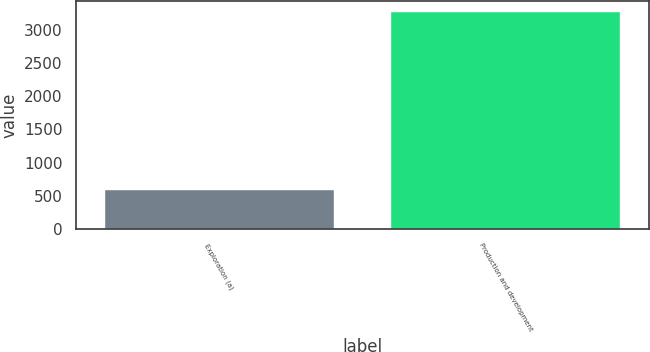Convert chart. <chart><loc_0><loc_0><loc_500><loc_500><bar_chart><fcel>Exploration (a)<fcel>Production and development<nl><fcel>592<fcel>3259<nl></chart> 